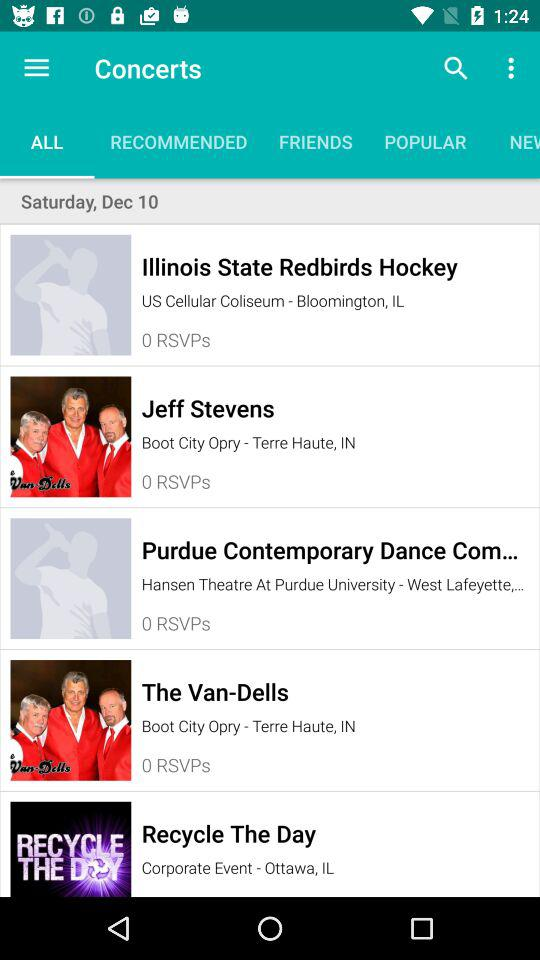How many events have 0 RSVPs?
Answer the question using a single word or phrase. 4 